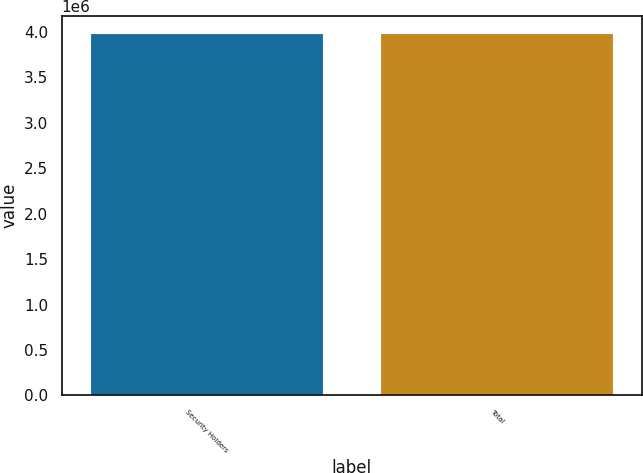Convert chart to OTSL. <chart><loc_0><loc_0><loc_500><loc_500><bar_chart><fcel>Security Holders<fcel>Total<nl><fcel>3.97573e+06<fcel>3.97573e+06<nl></chart> 